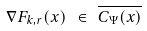Convert formula to latex. <formula><loc_0><loc_0><loc_500><loc_500>\nabla F _ { k , r } ( x ) \ \in \ \overline { C _ { \Psi } ( x ) }</formula> 